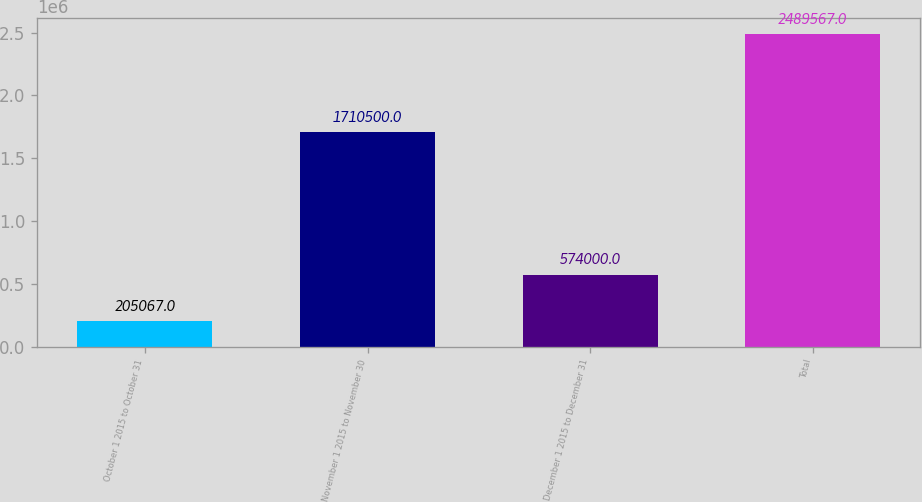Convert chart. <chart><loc_0><loc_0><loc_500><loc_500><bar_chart><fcel>October 1 2015 to October 31<fcel>November 1 2015 to November 30<fcel>December 1 2015 to December 31<fcel>Total<nl><fcel>205067<fcel>1.7105e+06<fcel>574000<fcel>2.48957e+06<nl></chart> 